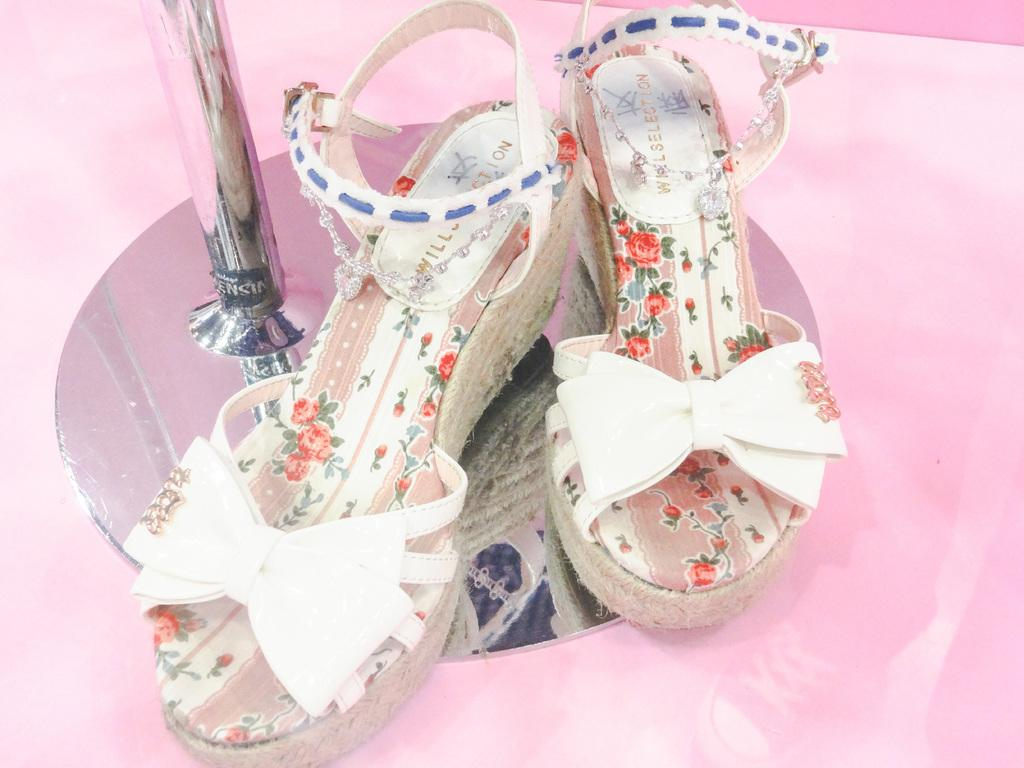What type of footwear is visible in the image? There are sandals in the image. Where are the sandals placed? The sandals are on a metal stand. What is the stand made of? The stand is made of metal. What color is the surface on which the metal stand is placed? The surface is pink. What type of fuel is used to power the vessel in the image? There is no vessel or fuel present in the image; it features sandals on a metal stand placed on a pink surface. 